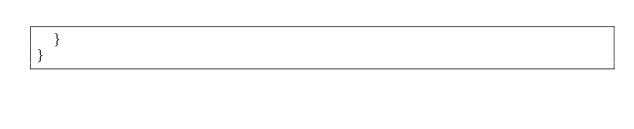Convert code to text. <code><loc_0><loc_0><loc_500><loc_500><_JavaScript_>	}
}
</code> 